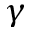Convert formula to latex. <formula><loc_0><loc_0><loc_500><loc_500>\gamma</formula> 